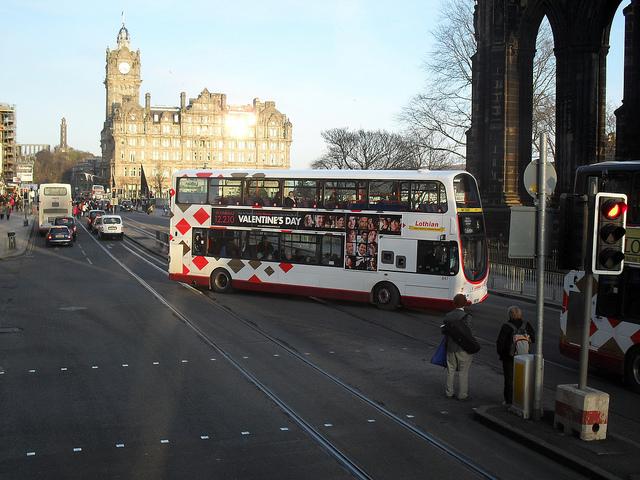What kind of bus is it?
Answer briefly. Double decker. Where is the bus at?
Quick response, please. London. What holiday name appears on the bus?
Be succinct. Valentine's day. 